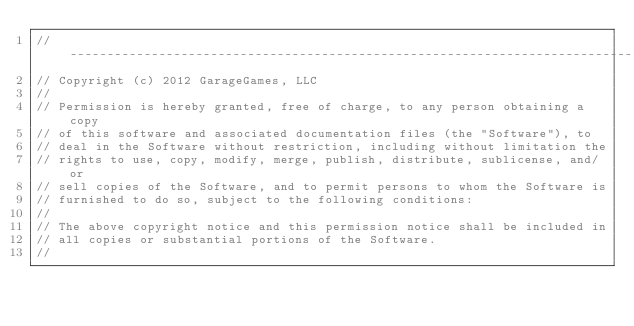Convert code to text. <code><loc_0><loc_0><loc_500><loc_500><_C_>//-----------------------------------------------------------------------------
// Copyright (c) 2012 GarageGames, LLC
//
// Permission is hereby granted, free of charge, to any person obtaining a copy
// of this software and associated documentation files (the "Software"), to
// deal in the Software without restriction, including without limitation the
// rights to use, copy, modify, merge, publish, distribute, sublicense, and/or
// sell copies of the Software, and to permit persons to whom the Software is
// furnished to do so, subject to the following conditions:
//
// The above copyright notice and this permission notice shall be included in
// all copies or substantial portions of the Software.
//</code> 